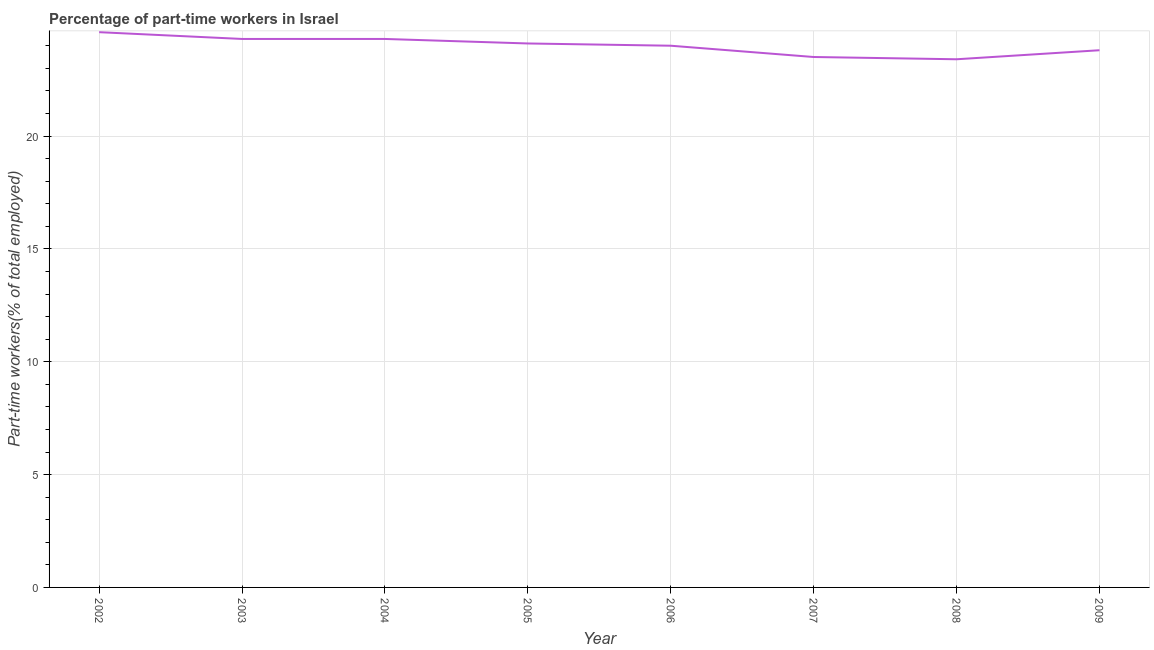What is the percentage of part-time workers in 2005?
Your answer should be compact. 24.1. Across all years, what is the maximum percentage of part-time workers?
Your answer should be very brief. 24.6. Across all years, what is the minimum percentage of part-time workers?
Provide a succinct answer. 23.4. In which year was the percentage of part-time workers minimum?
Offer a very short reply. 2008. What is the sum of the percentage of part-time workers?
Make the answer very short. 192. What is the difference between the percentage of part-time workers in 2002 and 2006?
Provide a short and direct response. 0.6. What is the average percentage of part-time workers per year?
Give a very brief answer. 24. What is the median percentage of part-time workers?
Provide a succinct answer. 24.05. Do a majority of the years between 2005 and 2008 (inclusive) have percentage of part-time workers greater than 8 %?
Your answer should be compact. Yes. What is the ratio of the percentage of part-time workers in 2005 to that in 2008?
Offer a very short reply. 1.03. Is the percentage of part-time workers in 2002 less than that in 2003?
Your answer should be very brief. No. Is the difference between the percentage of part-time workers in 2004 and 2007 greater than the difference between any two years?
Offer a terse response. No. What is the difference between the highest and the second highest percentage of part-time workers?
Offer a terse response. 0.3. What is the difference between the highest and the lowest percentage of part-time workers?
Your answer should be compact. 1.2. Does the percentage of part-time workers monotonically increase over the years?
Provide a short and direct response. No. How many lines are there?
Keep it short and to the point. 1. How many years are there in the graph?
Give a very brief answer. 8. What is the difference between two consecutive major ticks on the Y-axis?
Keep it short and to the point. 5. Does the graph contain any zero values?
Ensure brevity in your answer.  No. Does the graph contain grids?
Keep it short and to the point. Yes. What is the title of the graph?
Offer a terse response. Percentage of part-time workers in Israel. What is the label or title of the X-axis?
Your answer should be very brief. Year. What is the label or title of the Y-axis?
Your answer should be compact. Part-time workers(% of total employed). What is the Part-time workers(% of total employed) of 2002?
Keep it short and to the point. 24.6. What is the Part-time workers(% of total employed) in 2003?
Make the answer very short. 24.3. What is the Part-time workers(% of total employed) in 2004?
Your answer should be very brief. 24.3. What is the Part-time workers(% of total employed) in 2005?
Make the answer very short. 24.1. What is the Part-time workers(% of total employed) of 2006?
Offer a very short reply. 24. What is the Part-time workers(% of total employed) of 2007?
Your response must be concise. 23.5. What is the Part-time workers(% of total employed) in 2008?
Make the answer very short. 23.4. What is the Part-time workers(% of total employed) of 2009?
Your answer should be compact. 23.8. What is the difference between the Part-time workers(% of total employed) in 2002 and 2005?
Give a very brief answer. 0.5. What is the difference between the Part-time workers(% of total employed) in 2002 and 2006?
Provide a succinct answer. 0.6. What is the difference between the Part-time workers(% of total employed) in 2003 and 2008?
Keep it short and to the point. 0.9. What is the difference between the Part-time workers(% of total employed) in 2003 and 2009?
Offer a terse response. 0.5. What is the difference between the Part-time workers(% of total employed) in 2004 and 2005?
Your answer should be very brief. 0.2. What is the difference between the Part-time workers(% of total employed) in 2004 and 2007?
Keep it short and to the point. 0.8. What is the difference between the Part-time workers(% of total employed) in 2004 and 2009?
Your answer should be compact. 0.5. What is the difference between the Part-time workers(% of total employed) in 2005 and 2006?
Your answer should be very brief. 0.1. What is the difference between the Part-time workers(% of total employed) in 2005 and 2008?
Provide a succinct answer. 0.7. What is the difference between the Part-time workers(% of total employed) in 2005 and 2009?
Give a very brief answer. 0.3. What is the difference between the Part-time workers(% of total employed) in 2006 and 2008?
Ensure brevity in your answer.  0.6. What is the difference between the Part-time workers(% of total employed) in 2006 and 2009?
Provide a succinct answer. 0.2. What is the difference between the Part-time workers(% of total employed) in 2007 and 2008?
Offer a terse response. 0.1. What is the difference between the Part-time workers(% of total employed) in 2007 and 2009?
Make the answer very short. -0.3. What is the ratio of the Part-time workers(% of total employed) in 2002 to that in 2007?
Provide a short and direct response. 1.05. What is the ratio of the Part-time workers(% of total employed) in 2002 to that in 2008?
Provide a succinct answer. 1.05. What is the ratio of the Part-time workers(% of total employed) in 2002 to that in 2009?
Provide a succinct answer. 1.03. What is the ratio of the Part-time workers(% of total employed) in 2003 to that in 2006?
Provide a short and direct response. 1.01. What is the ratio of the Part-time workers(% of total employed) in 2003 to that in 2007?
Your answer should be compact. 1.03. What is the ratio of the Part-time workers(% of total employed) in 2003 to that in 2008?
Give a very brief answer. 1.04. What is the ratio of the Part-time workers(% of total employed) in 2003 to that in 2009?
Your answer should be very brief. 1.02. What is the ratio of the Part-time workers(% of total employed) in 2004 to that in 2006?
Make the answer very short. 1.01. What is the ratio of the Part-time workers(% of total employed) in 2004 to that in 2007?
Ensure brevity in your answer.  1.03. What is the ratio of the Part-time workers(% of total employed) in 2004 to that in 2008?
Keep it short and to the point. 1.04. What is the ratio of the Part-time workers(% of total employed) in 2005 to that in 2009?
Your answer should be very brief. 1.01. What is the ratio of the Part-time workers(% of total employed) in 2006 to that in 2007?
Make the answer very short. 1.02. What is the ratio of the Part-time workers(% of total employed) in 2006 to that in 2008?
Keep it short and to the point. 1.03. What is the ratio of the Part-time workers(% of total employed) in 2006 to that in 2009?
Offer a very short reply. 1.01. What is the ratio of the Part-time workers(% of total employed) in 2007 to that in 2008?
Make the answer very short. 1. What is the ratio of the Part-time workers(% of total employed) in 2008 to that in 2009?
Ensure brevity in your answer.  0.98. 